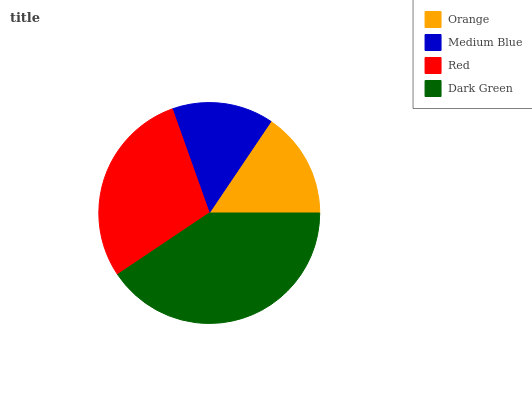Is Medium Blue the minimum?
Answer yes or no. Yes. Is Dark Green the maximum?
Answer yes or no. Yes. Is Red the minimum?
Answer yes or no. No. Is Red the maximum?
Answer yes or no. No. Is Red greater than Medium Blue?
Answer yes or no. Yes. Is Medium Blue less than Red?
Answer yes or no. Yes. Is Medium Blue greater than Red?
Answer yes or no. No. Is Red less than Medium Blue?
Answer yes or no. No. Is Red the high median?
Answer yes or no. Yes. Is Orange the low median?
Answer yes or no. Yes. Is Dark Green the high median?
Answer yes or no. No. Is Dark Green the low median?
Answer yes or no. No. 